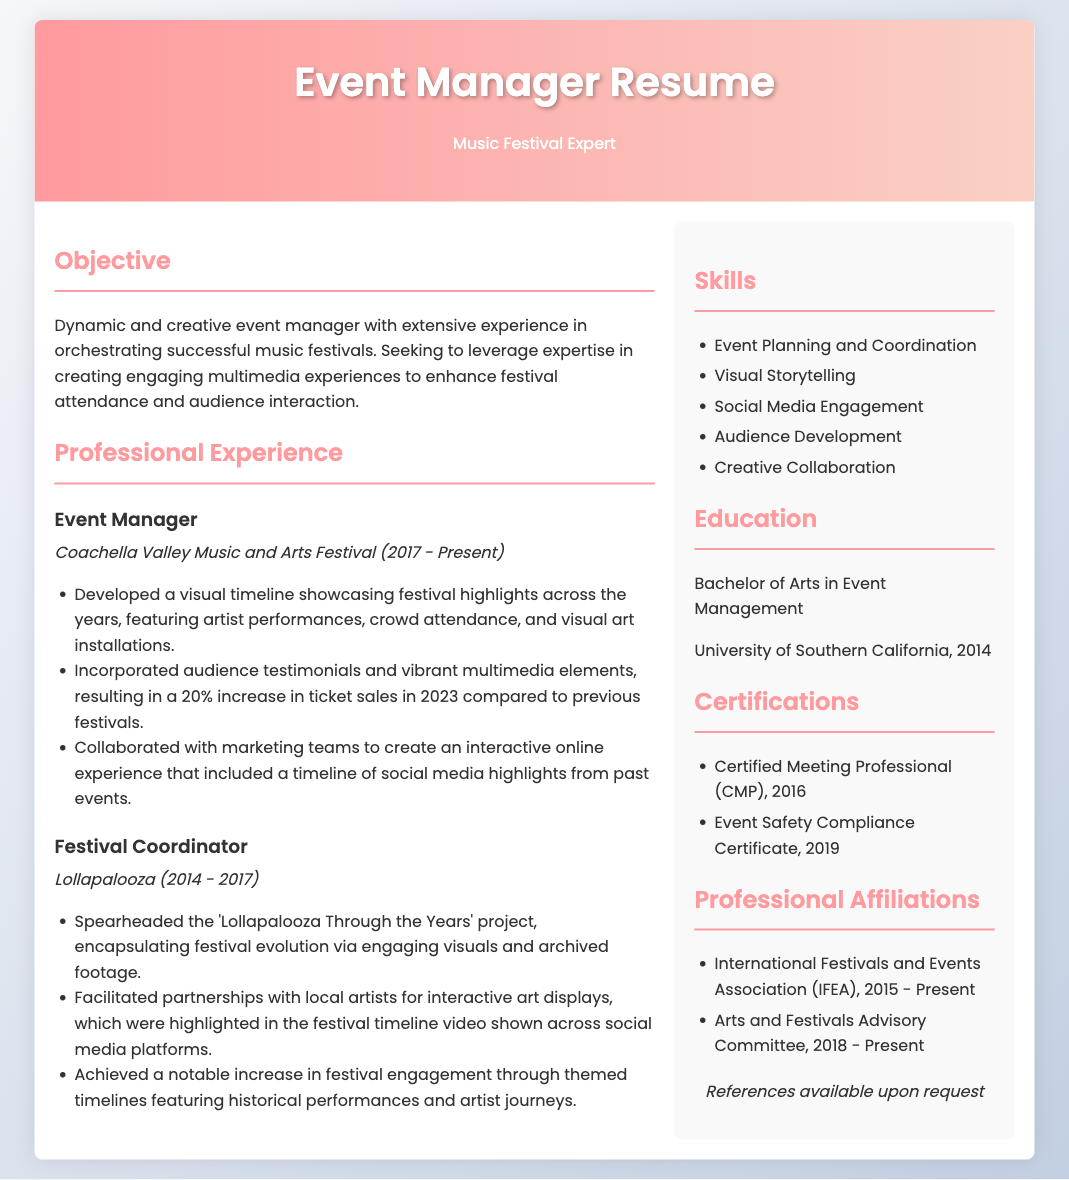What is the name of the festival mentioned in the resume? The festival highlighted in the resume is the Coachella Valley Music and Arts Festival.
Answer: Coachella Valley Music and Arts Festival What position did the individual hold at Lollapalooza? The individual's position at Lollapalooza is Festival Coordinator.
Answer: Festival Coordinator How many years of experience does the individual have at Coachella? The individual has been at Coachella from 2017 to Present, which is 7 years.
Answer: 7 years What was the percentage increase in ticket sales in 2023 compared to previous festivals? The ticket sales increased by 20% in 2023 compared to previous festivals.
Answer: 20% What type of degree does the individual hold? The individual holds a Bachelor of Arts in Event Management.
Answer: Bachelor of Arts in Event Management Which certification was obtained in 2016? The certification obtained in 2016 is the Certified Meeting Professional (CMP).
Answer: Certified Meeting Professional (CMP) What is the primary focus of the 'Lollapalooza Through the Years' project? The project encapsulated festival evolution via engaging visuals and archived footage.
Answer: Festival evolution via engaging visuals and archived footage How many professional affiliations are listed in the resume? There are two professional affiliations listed in the resume.
Answer: Two What is one of the skills mentioned in the resume? One of the skills mentioned is Event Planning and Coordination.
Answer: Event Planning and Coordination When did the individual graduate from university? The individual graduated from university in 2014.
Answer: 2014 